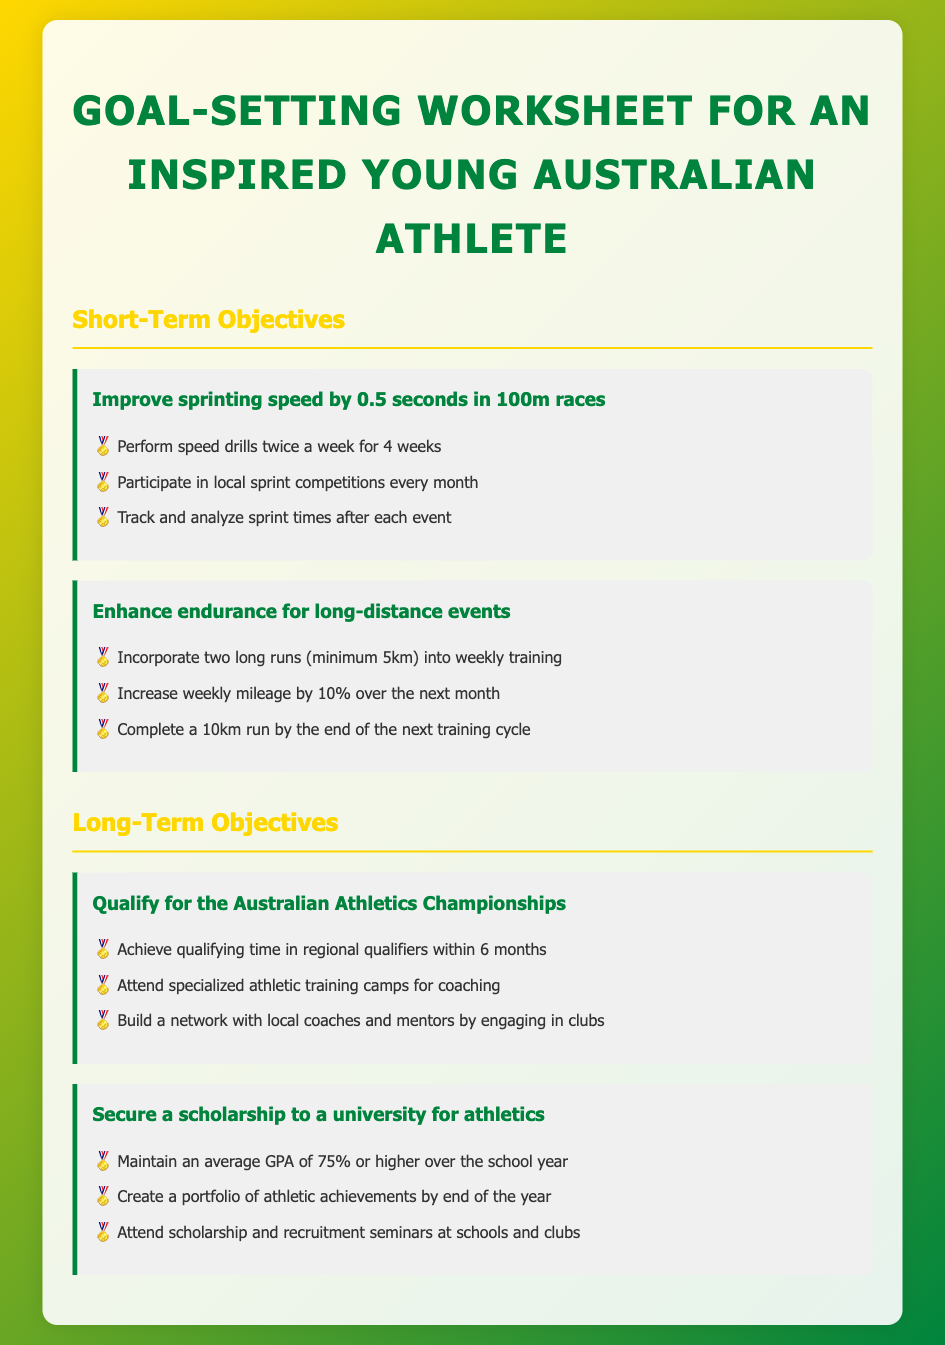What is the title of the worksheet? The title of the worksheet is clearly stated at the top of the document.
Answer: Goal-Setting Worksheet for an Inspired Young Australian Athlete How many short-term objectives are listed? The number of short-term objectives can be counted from the document's section under "Short-Term Objectives."
Answer: 2 What is the first milestone for improving sprinting speed? The milestone is the first item listed under the specific short-term objective in the document.
Answer: Perform speed drills twice a week for 4 weeks What is the goal for endurance enhancement? The goal is described as an objective in the section for short-term objectives, focusing on long-distance events.
Answer: Enhance endurance for long-distance events How long is the timeframe to qualify for the Australian Athletics Championships? The timeframe is mentioned in the context of achieving a specific milestone within a set period.
Answer: 6 months What GPA should be maintained for securing a scholarship? This numerical requirement is stated directly under the long-term objectives regarding securing a scholarship.
Answer: 75% What type of training is suggested for qualifying for championships? The type of training is referenced in the context of specialized camps for coaching.
Answer: Specialized athletic training camps What event should be completed by the end of the next training cycle? The specific event to be completed is mentioned as a goal under one of the objectives.
Answer: 10km run 